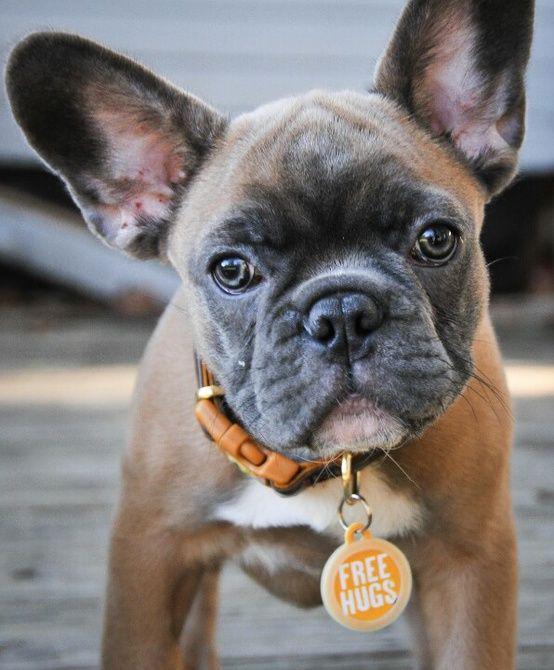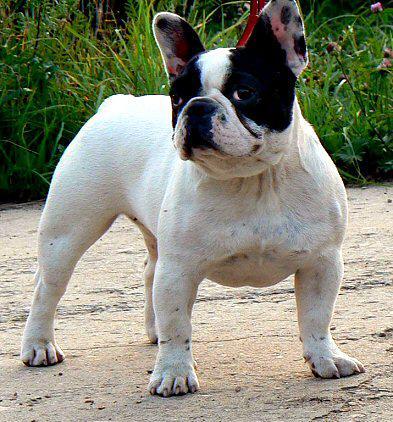The first image is the image on the left, the second image is the image on the right. Analyze the images presented: Is the assertion "At least one of the dogs is in the grass." valid? Answer yes or no. No. 